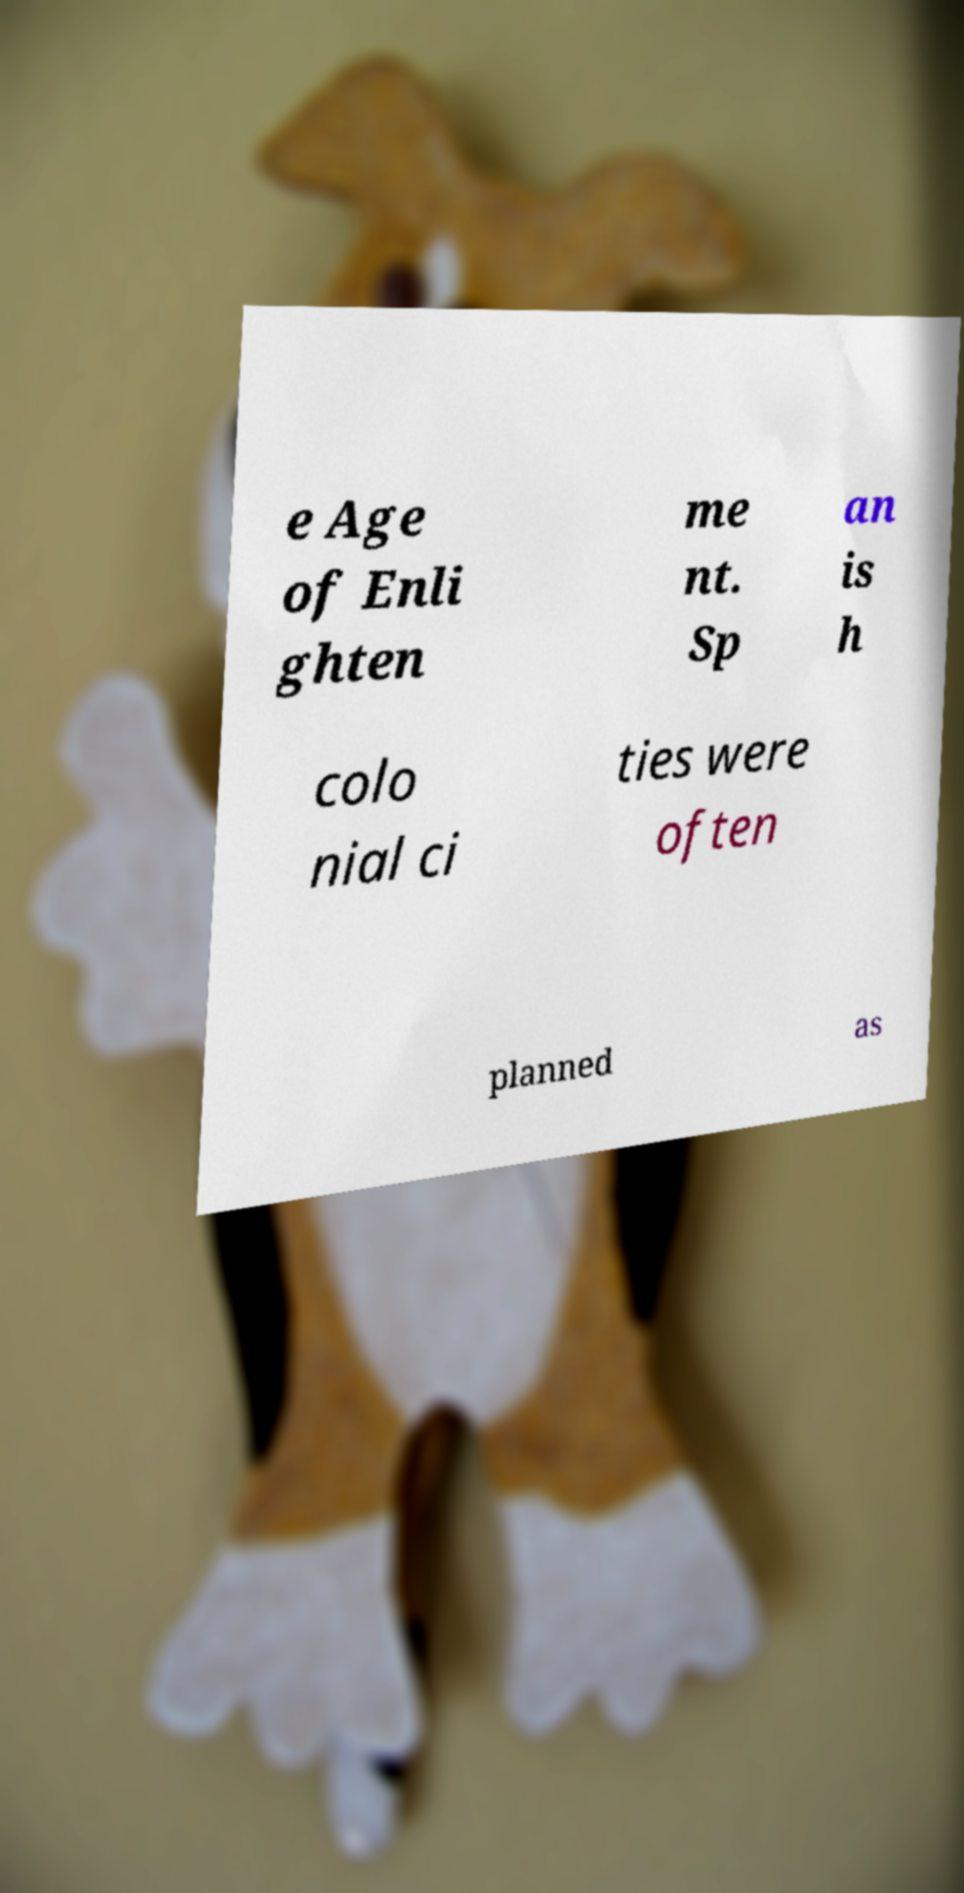Could you assist in decoding the text presented in this image and type it out clearly? e Age of Enli ghten me nt. Sp an is h colo nial ci ties were often planned as 